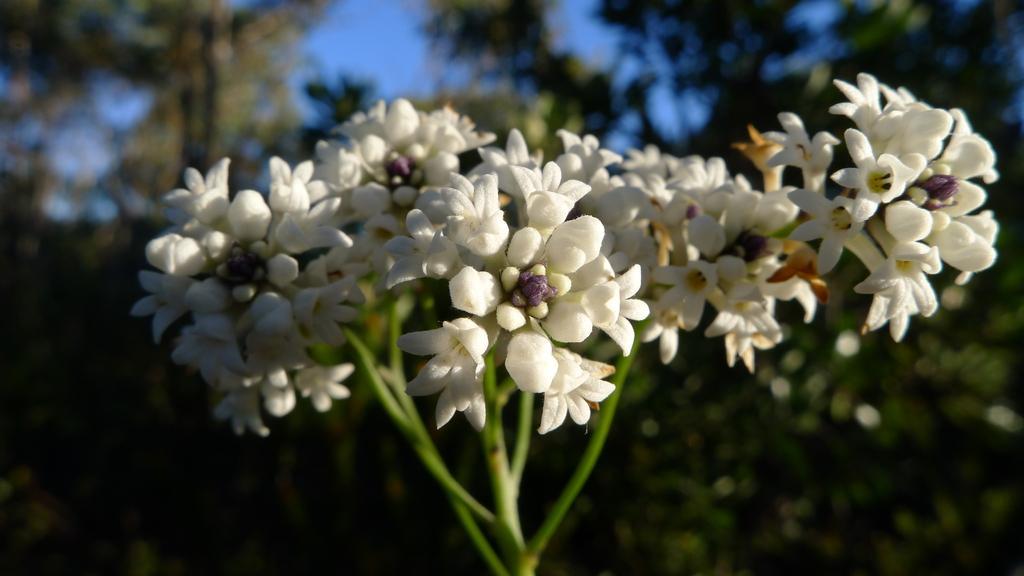How would you summarize this image in a sentence or two? In the center of the image we can see flowers. In the background we can see trees and sky. 